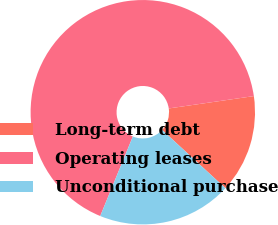<chart> <loc_0><loc_0><loc_500><loc_500><pie_chart><fcel>Long-term debt<fcel>Operating leases<fcel>Unconditional purchase<nl><fcel>14.13%<fcel>66.51%<fcel>19.36%<nl></chart> 